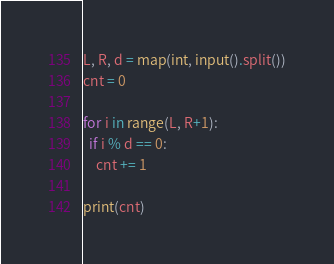Convert code to text. <code><loc_0><loc_0><loc_500><loc_500><_Python_>L, R, d = map(int, input().split())
cnt = 0

for i in range(L, R+1):
  if i % d == 0:
    cnt += 1

print(cnt)</code> 